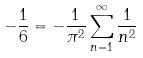Convert formula to latex. <formula><loc_0><loc_0><loc_500><loc_500>- \frac { 1 } { 6 } = - \frac { 1 } { \pi ^ { 2 } } \sum _ { n = 1 } ^ { \infty } \frac { 1 } { n ^ { 2 } }</formula> 